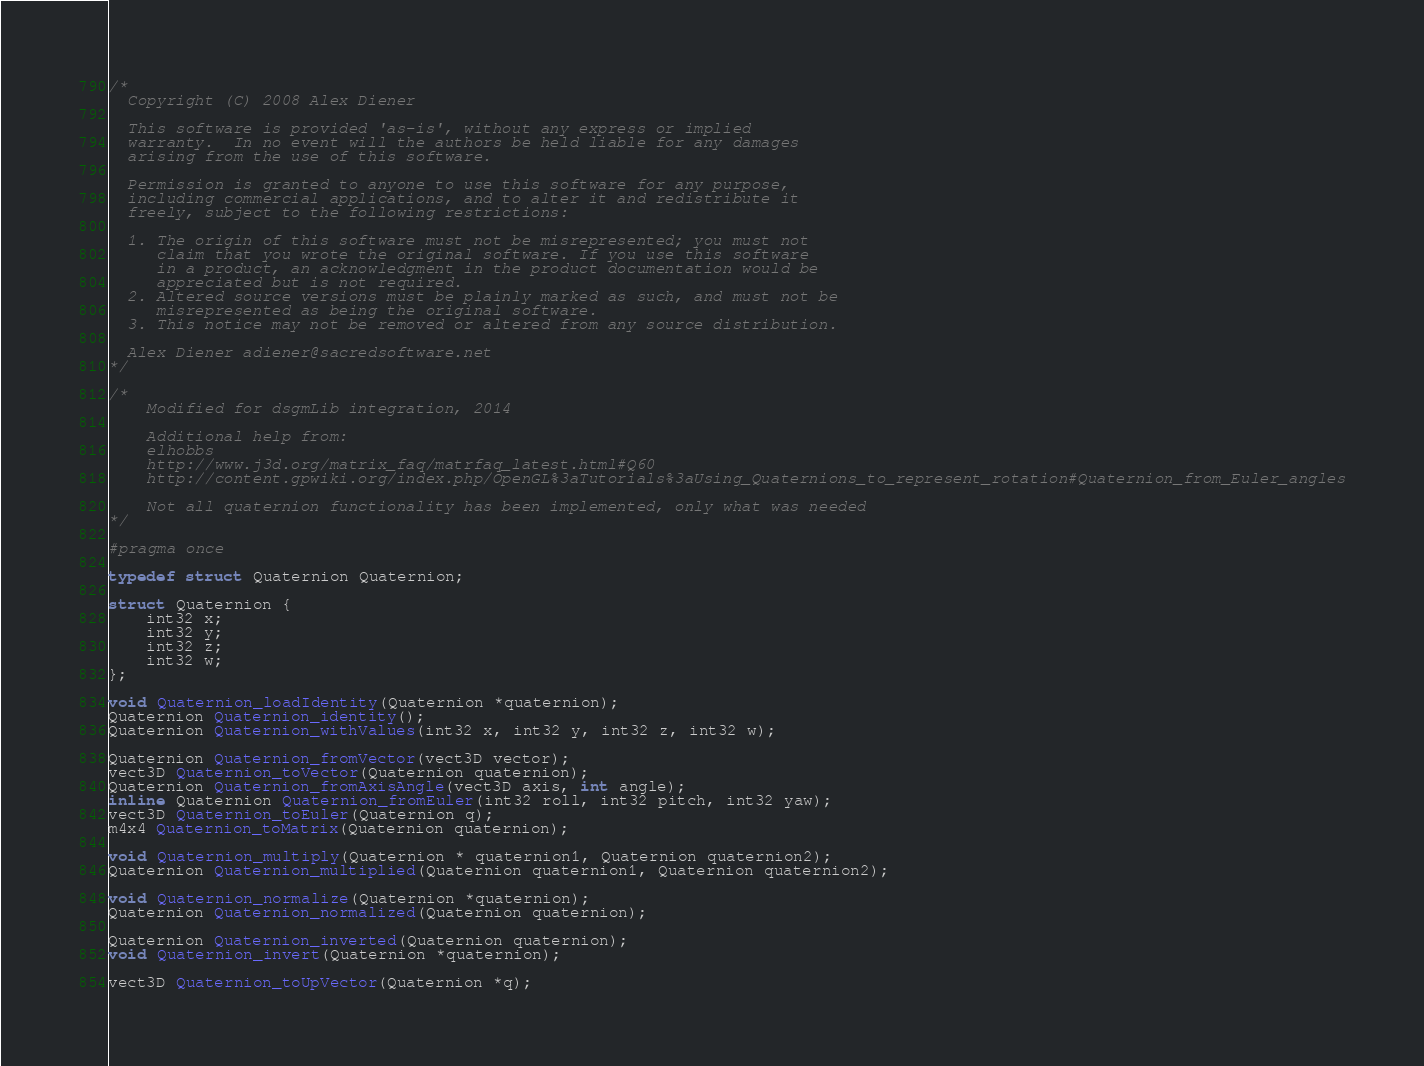<code> <loc_0><loc_0><loc_500><loc_500><_C_>/*
  Copyright (C) 2008 Alex Diener

  This software is provided 'as-is', without any express or implied
  warranty.  In no event will the authors be held liable for any damages
  arising from the use of this software.

  Permission is granted to anyone to use this software for any purpose,
  including commercial applications, and to alter it and redistribute it
  freely, subject to the following restrictions:

  1. The origin of this software must not be misrepresented; you must not
     claim that you wrote the original software. If you use this software
     in a product, an acknowledgment in the product documentation would be
     appreciated but is not required.
  2. Altered source versions must be plainly marked as such, and must not be
     misrepresented as being the original software.
  3. This notice may not be removed or altered from any source distribution.

  Alex Diener adiener@sacredsoftware.net
*/

/*
	Modified for dsgmLib integration, 2014
	
	Additional help from: 
	elhobbs
	http://www.j3d.org/matrix_faq/matrfaq_latest.html#Q60
	http://content.gpwiki.org/index.php/OpenGL%3aTutorials%3aUsing_Quaternions_to_represent_rotation#Quaternion_from_Euler_angles
	
	Not all quaternion functionality has been implemented, only what was needed
*/

#pragma once

typedef struct Quaternion Quaternion;

struct Quaternion {
	int32 x;
	int32 y;
	int32 z;
	int32 w;
};

void Quaternion_loadIdentity(Quaternion *quaternion);
Quaternion Quaternion_identity();
Quaternion Quaternion_withValues(int32 x, int32 y, int32 z, int32 w);

Quaternion Quaternion_fromVector(vect3D vector);
vect3D Quaternion_toVector(Quaternion quaternion);
Quaternion Quaternion_fromAxisAngle(vect3D axis, int angle);
inline Quaternion Quaternion_fromEuler(int32 roll, int32 pitch, int32 yaw);
vect3D Quaternion_toEuler(Quaternion q);
m4x4 Quaternion_toMatrix(Quaternion quaternion);

void Quaternion_multiply(Quaternion * quaternion1, Quaternion quaternion2);
Quaternion Quaternion_multiplied(Quaternion quaternion1, Quaternion quaternion2);

void Quaternion_normalize(Quaternion *quaternion);
Quaternion Quaternion_normalized(Quaternion quaternion);

Quaternion Quaternion_inverted(Quaternion quaternion);
void Quaternion_invert(Quaternion *quaternion);

vect3D Quaternion_toUpVector(Quaternion *q);
</code> 